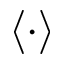Convert formula to latex. <formula><loc_0><loc_0><loc_500><loc_500>\left \langle \cdot \right \rangle</formula> 